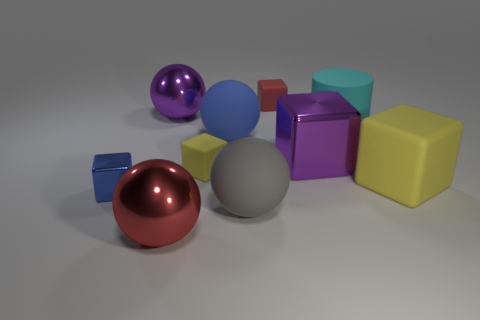Is there anything else that is the same shape as the cyan object?
Your answer should be compact. No. How many big shiny things are the same color as the big metallic cube?
Provide a succinct answer. 1. Do the red thing behind the small blue block and the big purple cube have the same material?
Offer a very short reply. No. Is the number of small yellow rubber blocks that are behind the blue metal object greater than the number of small red matte blocks on the left side of the big red metal object?
Keep it short and to the point. Yes. There is a purple cube that is the same size as the cyan rubber cylinder; what is it made of?
Ensure brevity in your answer.  Metal. What number of other things are the same material as the big yellow cube?
Your response must be concise. 5. Is the shape of the large purple thing on the left side of the blue ball the same as the big metal object in front of the large purple cube?
Make the answer very short. Yes. How many other things are there of the same color as the small metal object?
Your answer should be very brief. 1. Is the material of the small thing that is right of the big blue matte thing the same as the large cube that is behind the large yellow matte cube?
Your answer should be compact. No. Are there the same number of large purple metal balls in front of the big blue sphere and tiny metallic things that are right of the big purple metallic sphere?
Offer a very short reply. Yes. 